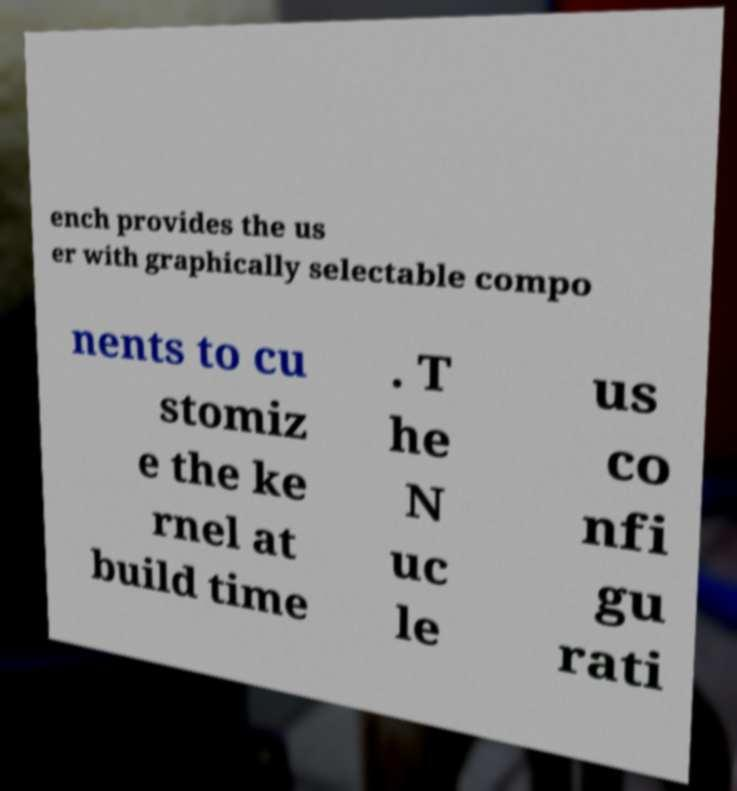Please identify and transcribe the text found in this image. ench provides the us er with graphically selectable compo nents to cu stomiz e the ke rnel at build time . T he N uc le us co nfi gu rati 